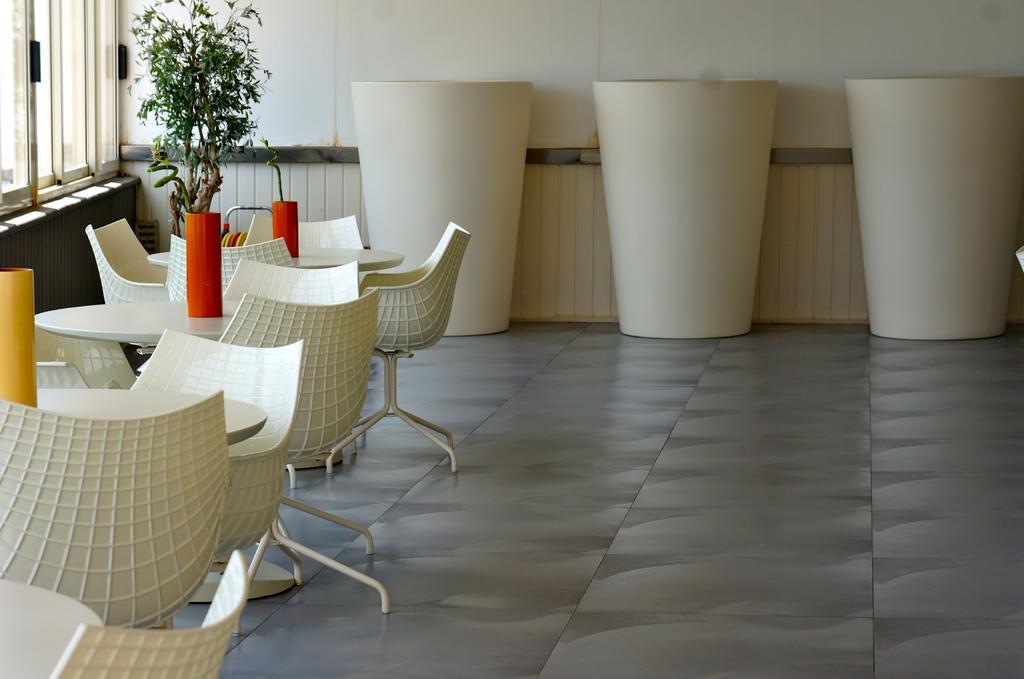In one or two sentences, can you explain what this image depicts? On the left there are tables, chairs, plant, windows, wall and other objects. In the foreground it is floor. In the middle there are some white color objects. At the top it is well. 